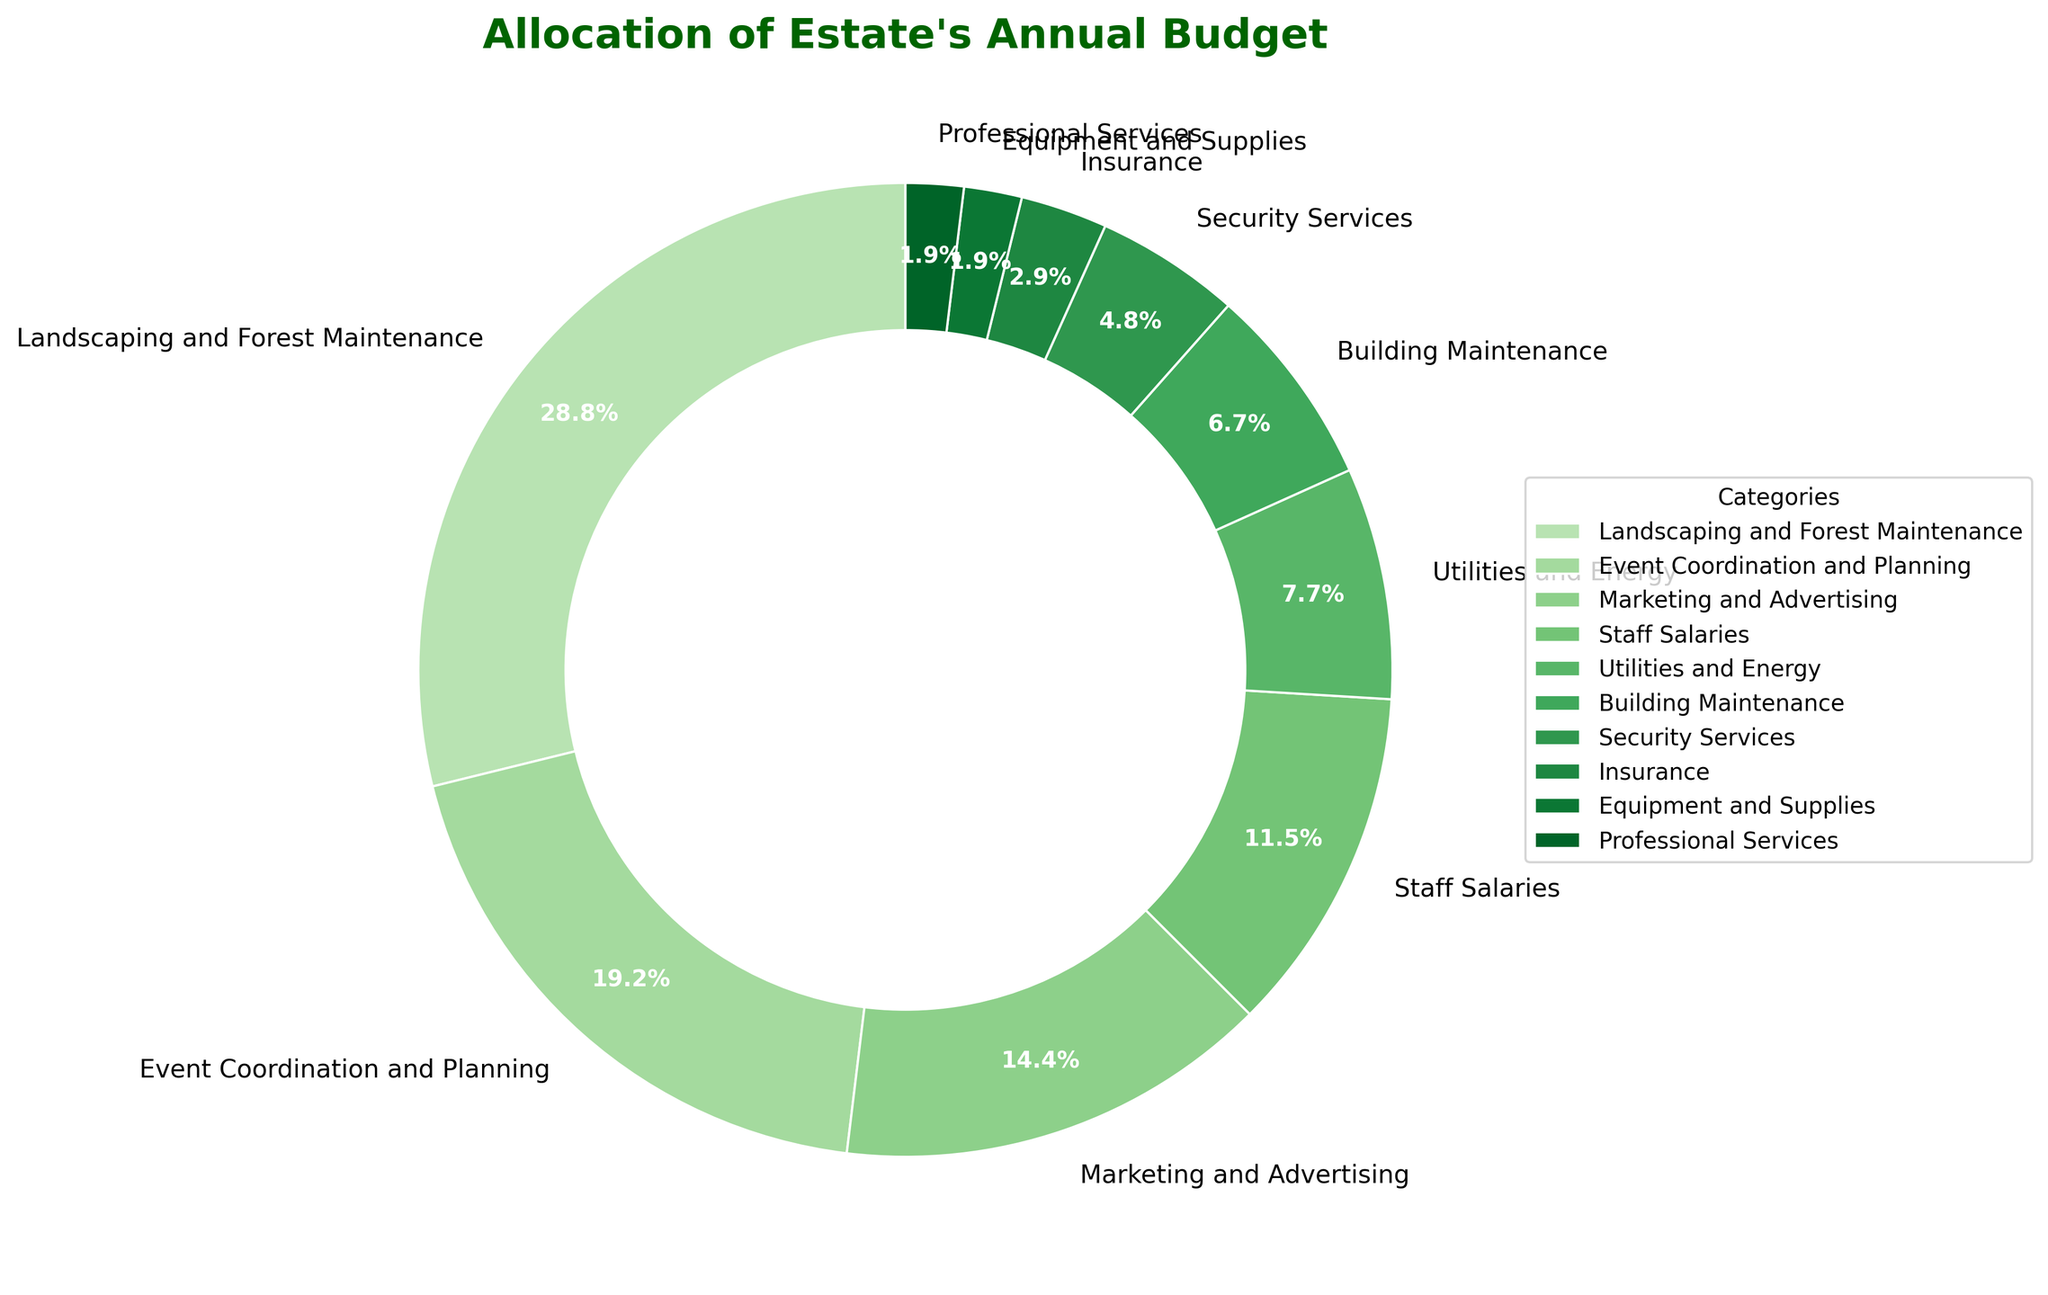What is the largest portion of the estate's annual budget allocated to? By looking at the pie chart, the largest slice represents "Landscaping and Forest Maintenance" with 30%.
Answer: Landscaping and Forest Maintenance Which category has a larger budget allocation: Event Coordination and Planning or Marketing and Advertising? By comparing the sizes of the slices, "Event Coordination and Planning" has 20% whereas "Marketing and Advertising" has 15%. 20% is greater than 15%.
Answer: Event Coordination and Planning How much budget is allocated to Utilities and Energy and Insurance combined? "Utilities and Energy" is 8% and "Insurance" is 3%. Adding these values gives 8% + 3% = 11%.
Answer: 11% Which categories have a budget allocation of less than 5%? Identifiable by the smaller slices, "Security Services" (5%), "Insurance" (3%), "Equipment and Supplies" (2%), and "Professional Services" (2%) each have less than 5%.
Answer: Security Services, Insurance, Equipment and Supplies, Professional Services Is Marketing and Advertising allocated more budget than Building Maintenance? The slices show that "Marketing and Advertising" is allocated 15%, which is indeed more than "Building Maintenance" with 7%.
Answer: Yes What is the total budget percentage allocated to Staff Salaries and Event Coordination and Planning? "Staff Salaries" is 12% and "Event Coordination and Planning" is 20%. Combining these gives 12% + 20% = 32%.
Answer: 32% How does the allocation for Building Maintenance compare to Equipment and Supplies? Comparing the slices, Building Maintenance has a budget of 7% while Equipment and Supplies have 2%. The allocation for Building Maintenance is greater.
Answer: Building Maintenance is greater What percentage of the budget is designated for areas not including Landscaping and Forest Maintenance and Event Coordination and Planning? First, add Landscaping and Forest Maintenance (30%) and Event Coordination and Planning (20%) which is 50%. Subtracting this from 100% gives 100% - 50% = 50%.
Answer: 50% What categories fall between Professional Services and Utilities and Energy in terms of budget allocation? Professional Services has a 2% allocation and Utilities and Energy has 8%. The categories between them are Building Maintenance (7%), Staff Salaries (12%), and Marketing and Advertising (15%).
Answer: Building Maintenance, Staff Salaries, Marketing and Advertising What is the median budget allocation percentage among all categories? Listing the budget percentages in ascending order: 2%, 2%, 3%, 5%, 7%, 8%, 12%, 15%, 20%, 30%. The middle two numbers (7% and 8%) need to be averaged, so (7+8)/2=7.5%.
Answer: 7.5% 